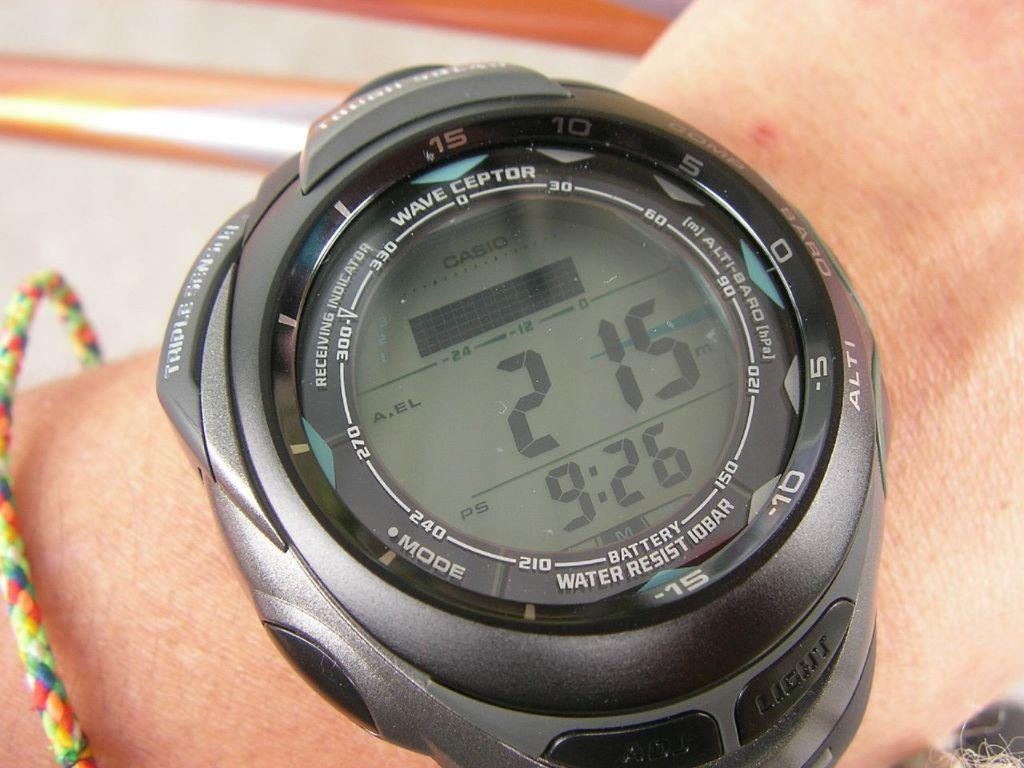Provide a one-sentence caption for the provided image. The front of a black Casio watch has many different functions. 